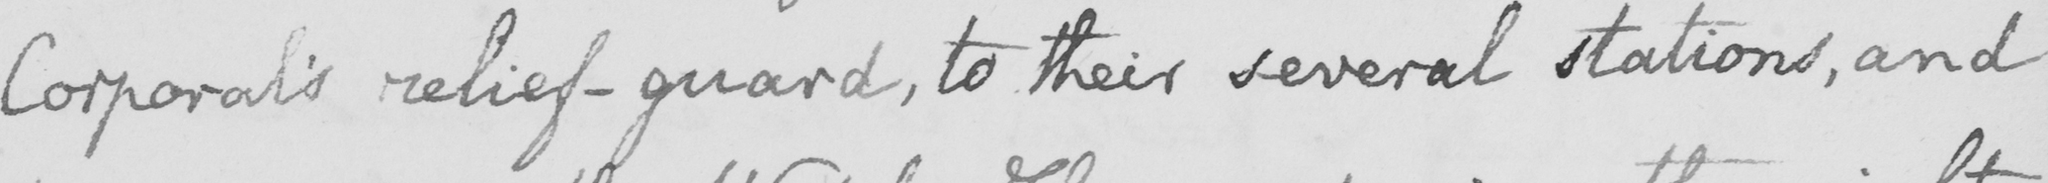Can you tell me what this handwritten text says? Corporal ' s relief-guard , to their several stations , and 